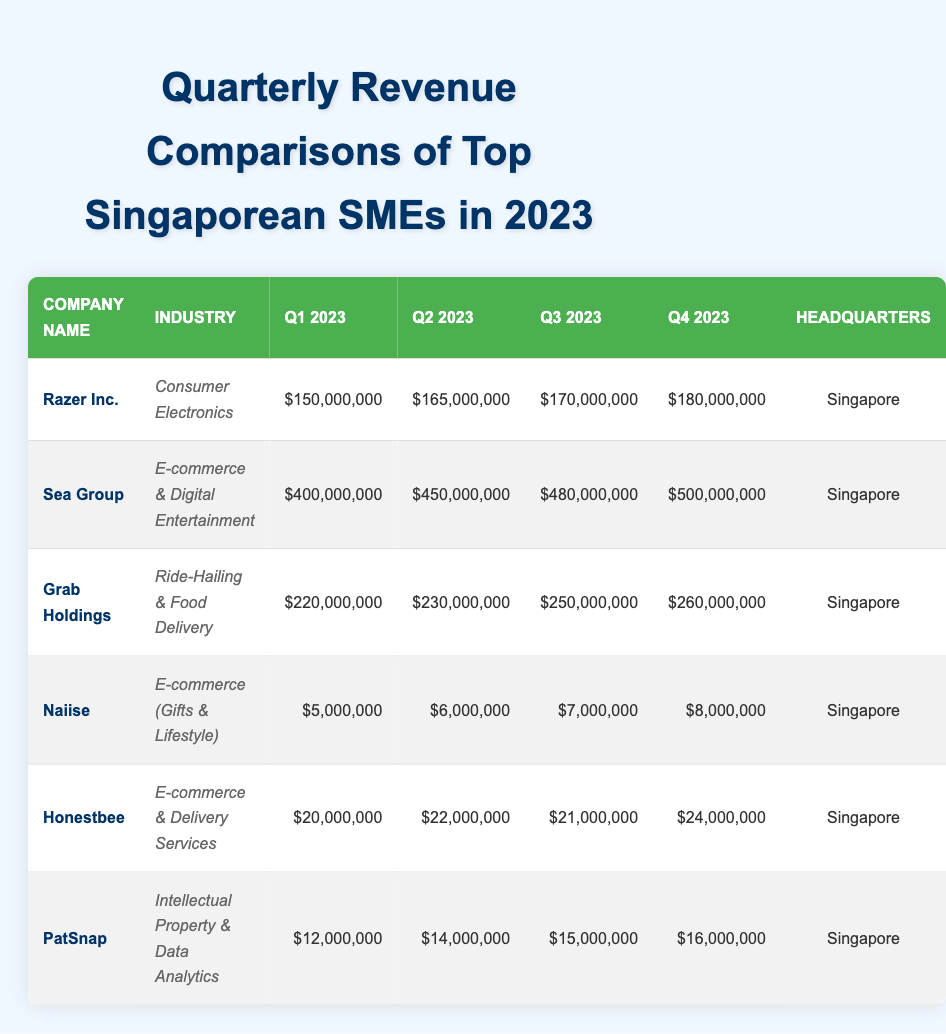What's the total revenue for Sea Group in Q4 2023? Sea Group's Q4 2023 revenue is listed as $500,000,000.
Answer: $500,000,000 What is the revenue increase from Q1 to Q2 2023 for Razer Inc.? Razer Inc.'s Q1 2023 revenue is $150,000,000, and Q2 is $165,000,000. The increase is $165,000,000 - $150,000,000 = $15,000,000.
Answer: $15,000,000 Which company had the highest revenue in Q3 2023? Reviewing the table, Sea Group had the highest revenue in Q3 2023 at $480,000,000.
Answer: Sea Group What was the percentage growth of Grab Holdings from Q1 to Q4 2023? Grab Holdings' Q1 revenue is $220,000,000 and Q4 revenue is $260,000,000. The growth is calculated as (($260,000,000 - $220,000,000) / $220,000,000) * 100 = 18.18%.
Answer: 18.18% Did Naiise have a revenue decrease in any quarter in 2023? Naiise's revenues in the quarters are consistent and show an increase: $5,000,000 in Q1, $6,000,000 in Q2, $7,000,000 in Q3, and $8,000,000 in Q4, indicating no decrease.
Answer: No What is the average revenue for PatSnap across all four quarters of 2023? PatSnap's revenues are $12,000,000 (Q1), $14,000,000 (Q2), $15,000,000 (Q3), and $16,000,000 (Q4). The average is (12 + 14 + 15 + 16) / 4 = 57 / 4 = $14,250,000.
Answer: $14,250,000 How much more revenue did Sea Group generate compared to Grab Holdings in Q2 2023? Sea Group's Q2 revenue is $450,000,000, while Grab Holdings' Q2 revenue is $230,000,000. The difference is $450,000,000 - $230,000,000 = $220,000,000.
Answer: $220,000,000 Which industry does Razer Inc. belong to, and how much revenue did it generate in Q4 2023? Razer Inc. is in the Consumer Electronics industry and generated $180,000,000 in Q4 2023.
Answer: Consumer Electronics, $180,000,000 What is the revenue trend for Honestbee across the four quarters? Honestbee's revenue shows fluctuations with $20,000,000 (Q1), $22,000,000 (Q2), $21,000,000 (Q3), and $24,000,000 (Q4), indicating a general increase towards the end but with a small dip in Q3.
Answer: Fluctuating trend with a general increase Which company demonstrated the most consistent revenue growth throughout 2023? Razer Inc. shows a steady increase every quarter: $150,000,000 (Q1) to $180,000,000 (Q4) without any drop in between.
Answer: Razer Inc 